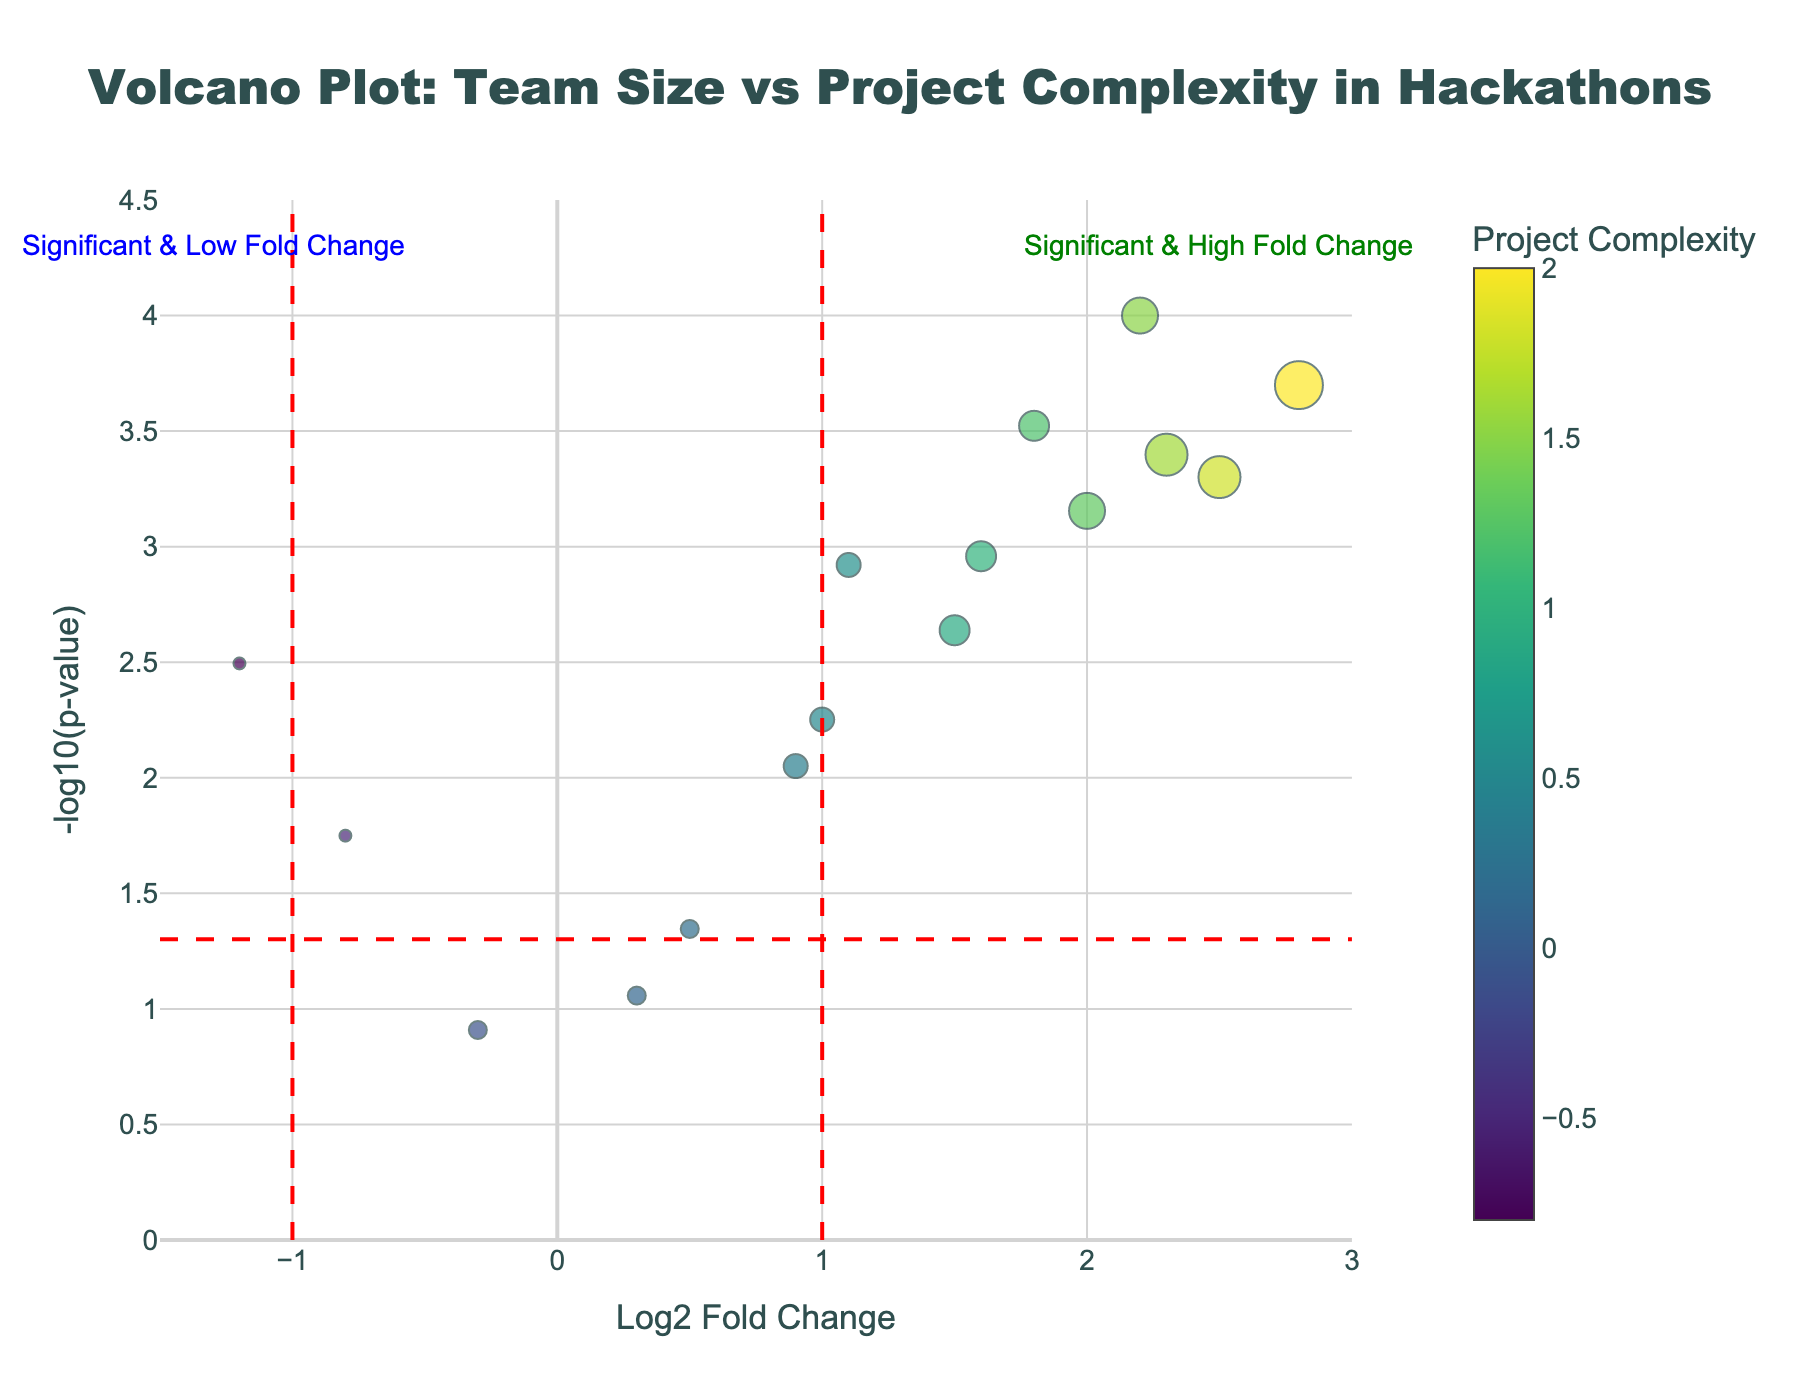What is the title of the plot? The title is usually located at the top center of the plot. In this case, it reads: "Volcano Plot: Team Size vs Project Complexity in Hackathons".
Answer: Volcano Plot: Team Size vs Project Complexity in Hackathons How many data points are there in the plot? Each marker represents a data point in the figure, so we count the markers. There are 15 data points.
Answer: 15 Which team size has the highest Log2 Fold Change? The x-axis represents Log2 Fold Change. Among all data points, the one with the highest Log2 Fold Change appears at 2.8, corresponding to a team size of 8.
Answer: Team size of 8 Which data point represents the lowest p-value? The y-axis represents -log10(p-value), so the highest y-value corresponds to the lowest p-value. The data point at (2.2, 4.0) has the lowest p-value, and it corresponds to a team size of 6.
Answer: Team size of 6 How many data points are statistically significant based on the p-value threshold of 0.05? Data points above the horizontal red dashed line are significant. We count the markers above this line; there are 12 data points.
Answer: 12 Compare the Log2 Fold Change between the teams of size 5 and 6. Which is greater? Locate the data points with team sizes of 5 and 6. The data points for size 5 have fold changes of (1.8, 1.5, 1.6), and size 6 has (2.2, 2.0). The Log2 Fold Change of team size 6 is greater.
Answer: Team size of 6 For the team size of 4, what is the average Project Complexity? Identify the data points corresponding to team size 4. Their Project Complexities are 0.6, 0.4, and 0.5. Calculate the average: (0.6 + 0.4 + 0.5) / 3 = 0.5.
Answer: 0.5 Which team size shows the lowest project complexity? Examine the color scale and find the darkest point, which represents the lowest Project Complexity. The data point at (-1.2, ~2.5) corresponds to a team size of 2 and shows the lowest project complexity.
Answer: Team size of 2 What is the significance of the vertical lines in the plot? The vertical lines are at Log2 Fold Change values of -1 and 1. They indicate thresholds for significant fold changes in either direction.
Answer: Indicate fold change significance thresholds What does the color of a marker represent in the plot? The color of a marker, based on the color scale on the right, represents the Project Complexity associated with that data point.
Answer: Project Complexity 